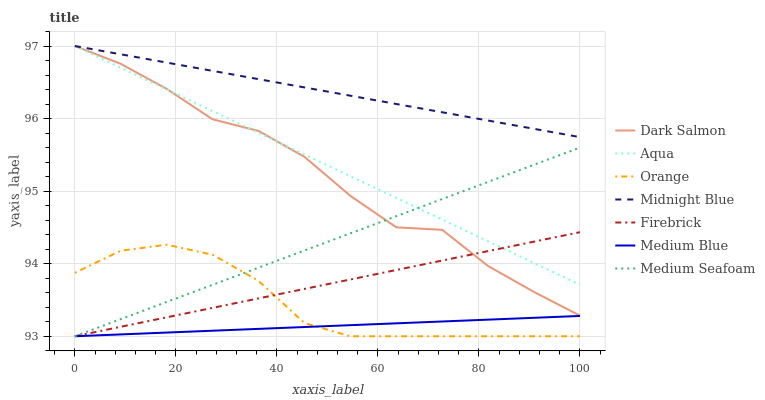Does Medium Blue have the minimum area under the curve?
Answer yes or no. Yes. Does Midnight Blue have the maximum area under the curve?
Answer yes or no. Yes. Does Aqua have the minimum area under the curve?
Answer yes or no. No. Does Aqua have the maximum area under the curve?
Answer yes or no. No. Is Aqua the smoothest?
Answer yes or no. Yes. Is Dark Salmon the roughest?
Answer yes or no. Yes. Is Firebrick the smoothest?
Answer yes or no. No. Is Firebrick the roughest?
Answer yes or no. No. Does Firebrick have the lowest value?
Answer yes or no. Yes. Does Aqua have the lowest value?
Answer yes or no. No. Does Dark Salmon have the highest value?
Answer yes or no. Yes. Does Firebrick have the highest value?
Answer yes or no. No. Is Medium Blue less than Midnight Blue?
Answer yes or no. Yes. Is Midnight Blue greater than Medium Seafoam?
Answer yes or no. Yes. Does Aqua intersect Midnight Blue?
Answer yes or no. Yes. Is Aqua less than Midnight Blue?
Answer yes or no. No. Is Aqua greater than Midnight Blue?
Answer yes or no. No. Does Medium Blue intersect Midnight Blue?
Answer yes or no. No. 